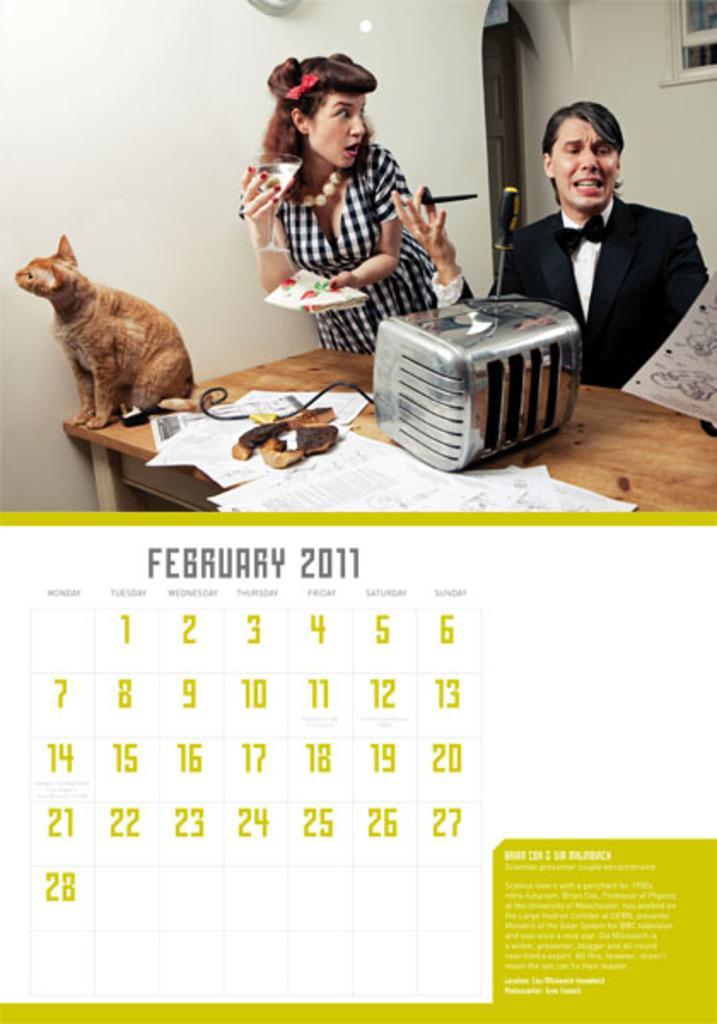Could you give a brief overview of what you see in this image? In the image there is calendar at the bottom and an image at the top. In that image there is a man with black jacket is sitting. Beside him there is a lady with black and white checkered dress is standing and she is holding glass in one hand and on the other hand there is an object. In front of them there is a table with oven, papers and a cat. Behind them there is a wall with door and window. 